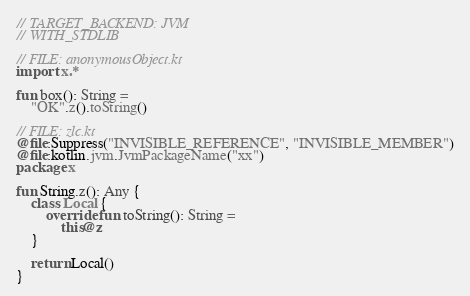<code> <loc_0><loc_0><loc_500><loc_500><_Kotlin_>// TARGET_BACKEND: JVM
// WITH_STDLIB

// FILE: anonymousObject.kt
import x.*

fun box(): String =
    "OK".z().toString()

// FILE: zlc.kt
@file:Suppress("INVISIBLE_REFERENCE", "INVISIBLE_MEMBER")
@file:kotlin.jvm.JvmPackageName("xx")
package x

fun String.z(): Any {
    class Local {
        override fun toString(): String =
            this@z
    }

    return Local()
}
</code> 